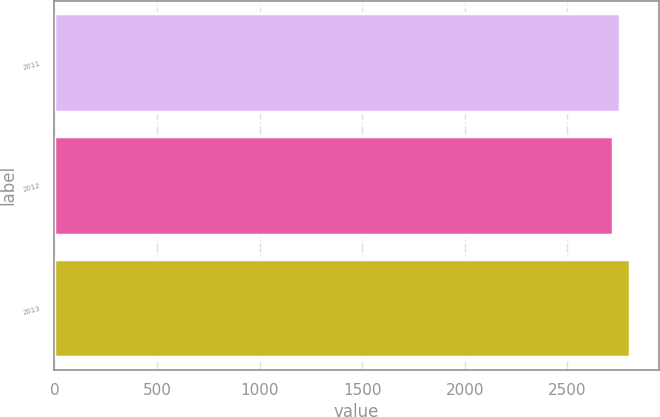<chart> <loc_0><loc_0><loc_500><loc_500><bar_chart><fcel>2011<fcel>2012<fcel>2013<nl><fcel>2756<fcel>2723<fcel>2806<nl></chart> 